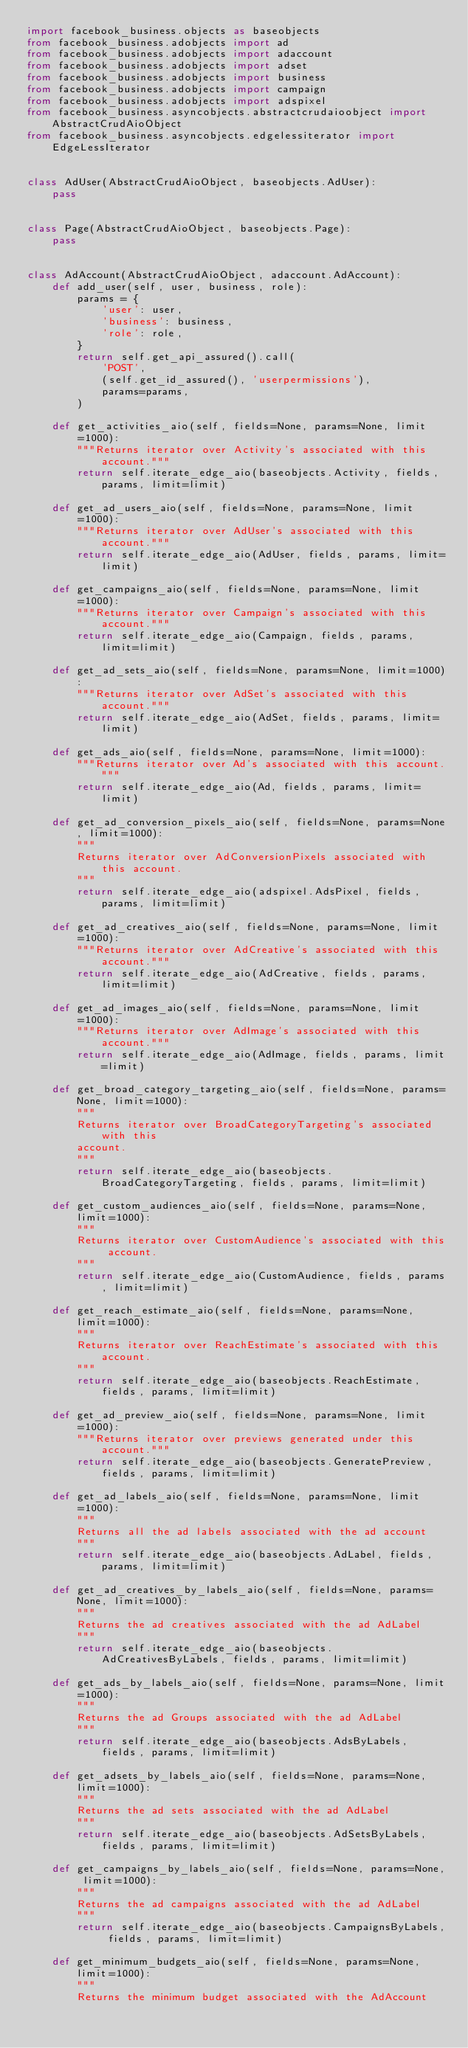<code> <loc_0><loc_0><loc_500><loc_500><_Python_>import facebook_business.objects as baseobjects
from facebook_business.adobjects import ad
from facebook_business.adobjects import adaccount
from facebook_business.adobjects import adset
from facebook_business.adobjects import business
from facebook_business.adobjects import campaign
from facebook_business.adobjects import adspixel
from facebook_business.asyncobjects.abstractcrudaioobject import AbstractCrudAioObject
from facebook_business.asyncobjects.edgelessiterator import EdgeLessIterator


class AdUser(AbstractCrudAioObject, baseobjects.AdUser):
    pass


class Page(AbstractCrudAioObject, baseobjects.Page):
    pass


class AdAccount(AbstractCrudAioObject, adaccount.AdAccount):
    def add_user(self, user, business, role):
        params = {
            'user': user,
            'business': business,
            'role': role,
        }
        return self.get_api_assured().call(
            'POST',
            (self.get_id_assured(), 'userpermissions'),
            params=params,
        )

    def get_activities_aio(self, fields=None, params=None, limit=1000):
        """Returns iterator over Activity's associated with this account."""
        return self.iterate_edge_aio(baseobjects.Activity, fields, params, limit=limit)

    def get_ad_users_aio(self, fields=None, params=None, limit=1000):
        """Returns iterator over AdUser's associated with this account."""
        return self.iterate_edge_aio(AdUser, fields, params, limit=limit)

    def get_campaigns_aio(self, fields=None, params=None, limit=1000):
        """Returns iterator over Campaign's associated with this account."""
        return self.iterate_edge_aio(Campaign, fields, params, limit=limit)

    def get_ad_sets_aio(self, fields=None, params=None, limit=1000):
        """Returns iterator over AdSet's associated with this account."""
        return self.iterate_edge_aio(AdSet, fields, params, limit=limit)

    def get_ads_aio(self, fields=None, params=None, limit=1000):
        """Returns iterator over Ad's associated with this account."""
        return self.iterate_edge_aio(Ad, fields, params, limit=limit)

    def get_ad_conversion_pixels_aio(self, fields=None, params=None, limit=1000):
        """
        Returns iterator over AdConversionPixels associated with this account.
        """
        return self.iterate_edge_aio(adspixel.AdsPixel, fields, params, limit=limit)

    def get_ad_creatives_aio(self, fields=None, params=None, limit=1000):
        """Returns iterator over AdCreative's associated with this account."""
        return self.iterate_edge_aio(AdCreative, fields, params, limit=limit)

    def get_ad_images_aio(self, fields=None, params=None, limit=1000):
        """Returns iterator over AdImage's associated with this account."""
        return self.iterate_edge_aio(AdImage, fields, params, limit=limit)

    def get_broad_category_targeting_aio(self, fields=None, params=None, limit=1000):
        """
        Returns iterator over BroadCategoryTargeting's associated with this
        account.
        """
        return self.iterate_edge_aio(baseobjects.BroadCategoryTargeting, fields, params, limit=limit)

    def get_custom_audiences_aio(self, fields=None, params=None, limit=1000):
        """
        Returns iterator over CustomAudience's associated with this account.
        """
        return self.iterate_edge_aio(CustomAudience, fields, params, limit=limit)

    def get_reach_estimate_aio(self, fields=None, params=None, limit=1000):
        """
        Returns iterator over ReachEstimate's associated with this account.
        """
        return self.iterate_edge_aio(baseobjects.ReachEstimate, fields, params, limit=limit)

    def get_ad_preview_aio(self, fields=None, params=None, limit=1000):
        """Returns iterator over previews generated under this account."""
        return self.iterate_edge_aio(baseobjects.GeneratePreview, fields, params, limit=limit)

    def get_ad_labels_aio(self, fields=None, params=None, limit=1000):
        """
        Returns all the ad labels associated with the ad account
        """
        return self.iterate_edge_aio(baseobjects.AdLabel, fields, params, limit=limit)

    def get_ad_creatives_by_labels_aio(self, fields=None, params=None, limit=1000):
        """
        Returns the ad creatives associated with the ad AdLabel
        """
        return self.iterate_edge_aio(baseobjects.AdCreativesByLabels, fields, params, limit=limit)

    def get_ads_by_labels_aio(self, fields=None, params=None, limit=1000):
        """
        Returns the ad Groups associated with the ad AdLabel
        """
        return self.iterate_edge_aio(baseobjects.AdsByLabels, fields, params, limit=limit)

    def get_adsets_by_labels_aio(self, fields=None, params=None, limit=1000):
        """
        Returns the ad sets associated with the ad AdLabel
        """
        return self.iterate_edge_aio(baseobjects.AdSetsByLabels, fields, params, limit=limit)

    def get_campaigns_by_labels_aio(self, fields=None, params=None, limit=1000):
        """
        Returns the ad campaigns associated with the ad AdLabel
        """
        return self.iterate_edge_aio(baseobjects.CampaignsByLabels, fields, params, limit=limit)

    def get_minimum_budgets_aio(self, fields=None, params=None, limit=1000):
        """
        Returns the minimum budget associated with the AdAccount</code> 